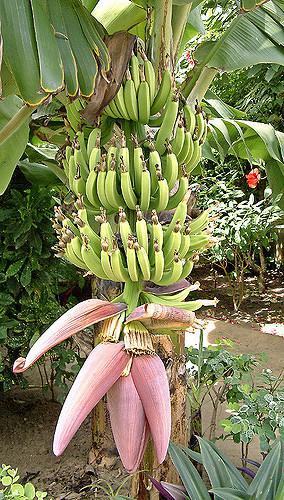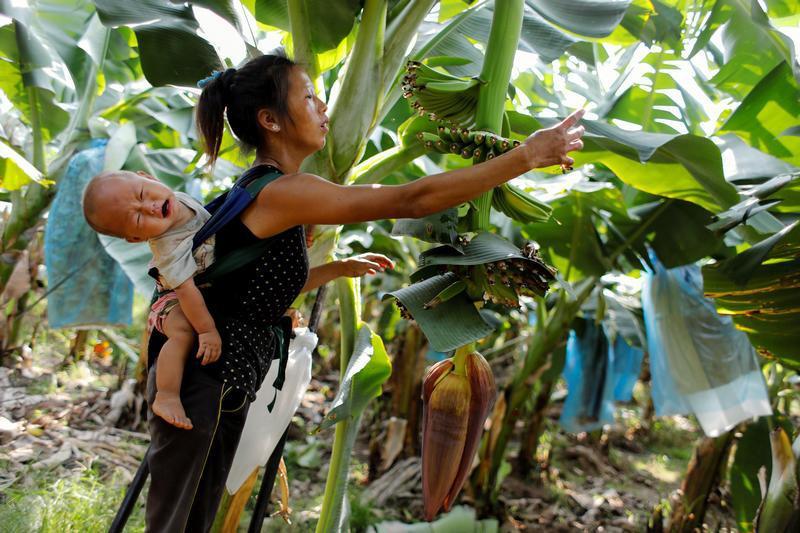The first image is the image on the left, the second image is the image on the right. Examine the images to the left and right. Is the description "The image to the right is focused on the red flowering bottom of a banana bunch." accurate? Answer yes or no. No. The first image is the image on the left, the second image is the image on the right. Assess this claim about the two images: "The righthand image shows a big purple flower with red underside of a petal visible below a bunch of green bananas, but the left image does not show any red undersides of petals.". Correct or not? Answer yes or no. No. 